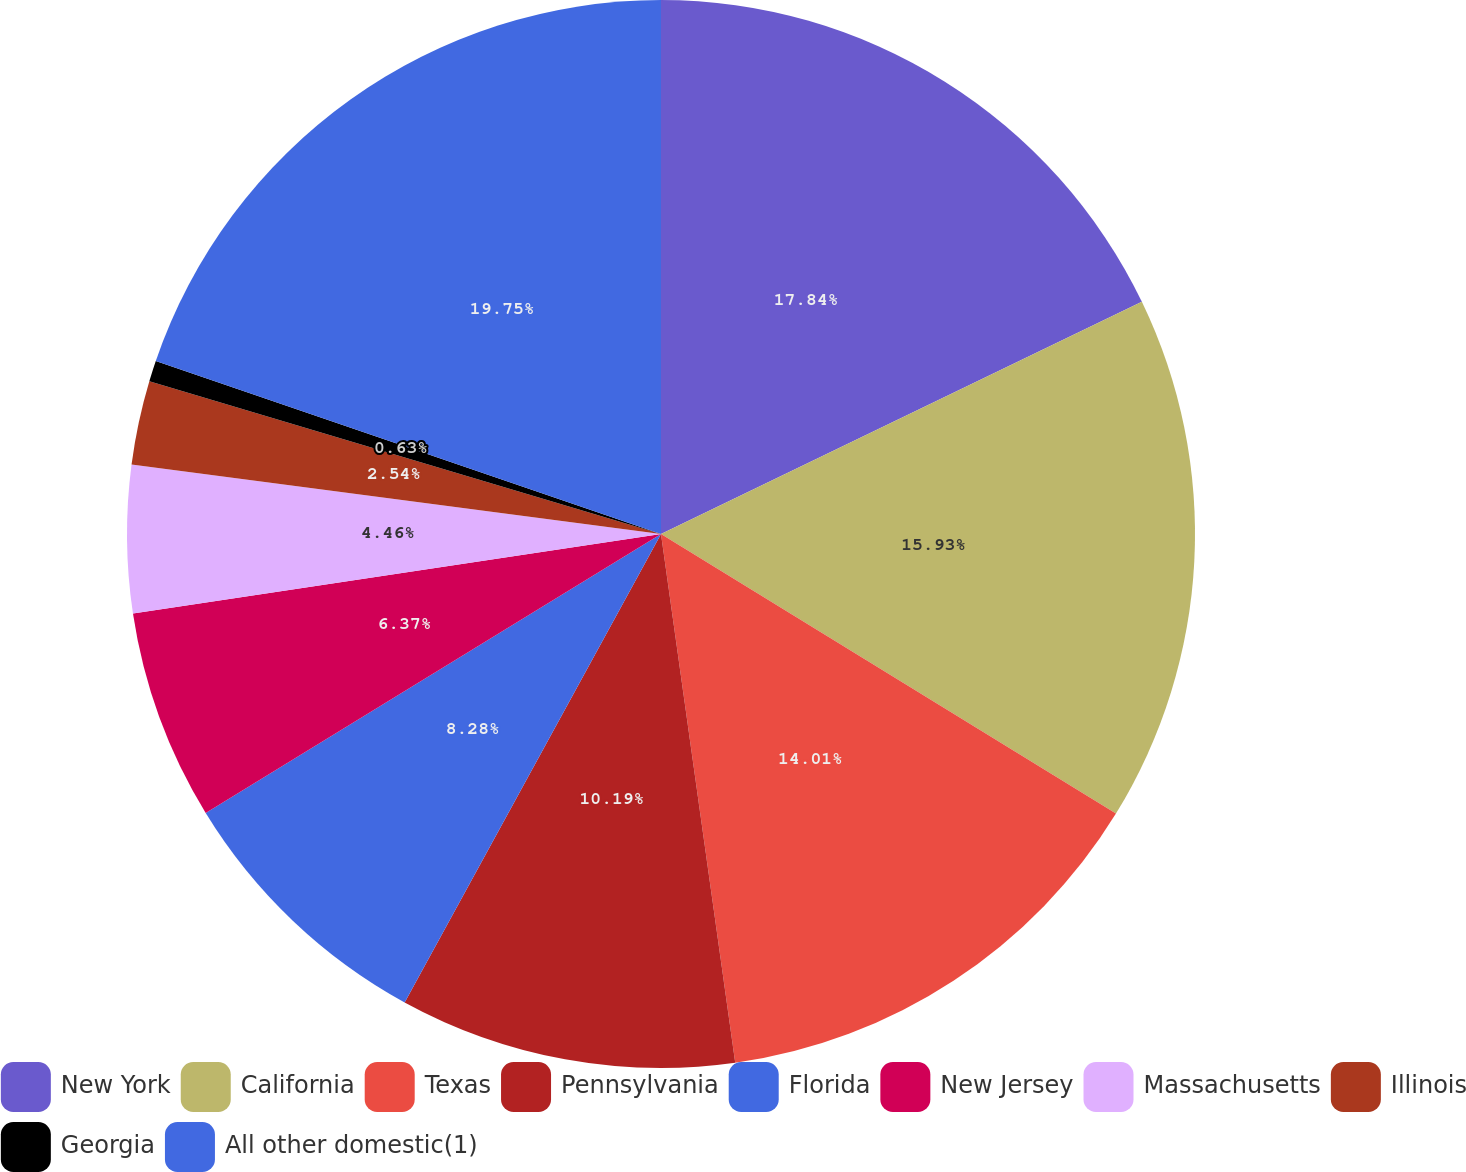Convert chart to OTSL. <chart><loc_0><loc_0><loc_500><loc_500><pie_chart><fcel>New York<fcel>California<fcel>Texas<fcel>Pennsylvania<fcel>Florida<fcel>New Jersey<fcel>Massachusetts<fcel>Illinois<fcel>Georgia<fcel>All other domestic(1)<nl><fcel>17.84%<fcel>15.93%<fcel>14.01%<fcel>10.19%<fcel>8.28%<fcel>6.37%<fcel>4.46%<fcel>2.54%<fcel>0.63%<fcel>19.75%<nl></chart> 